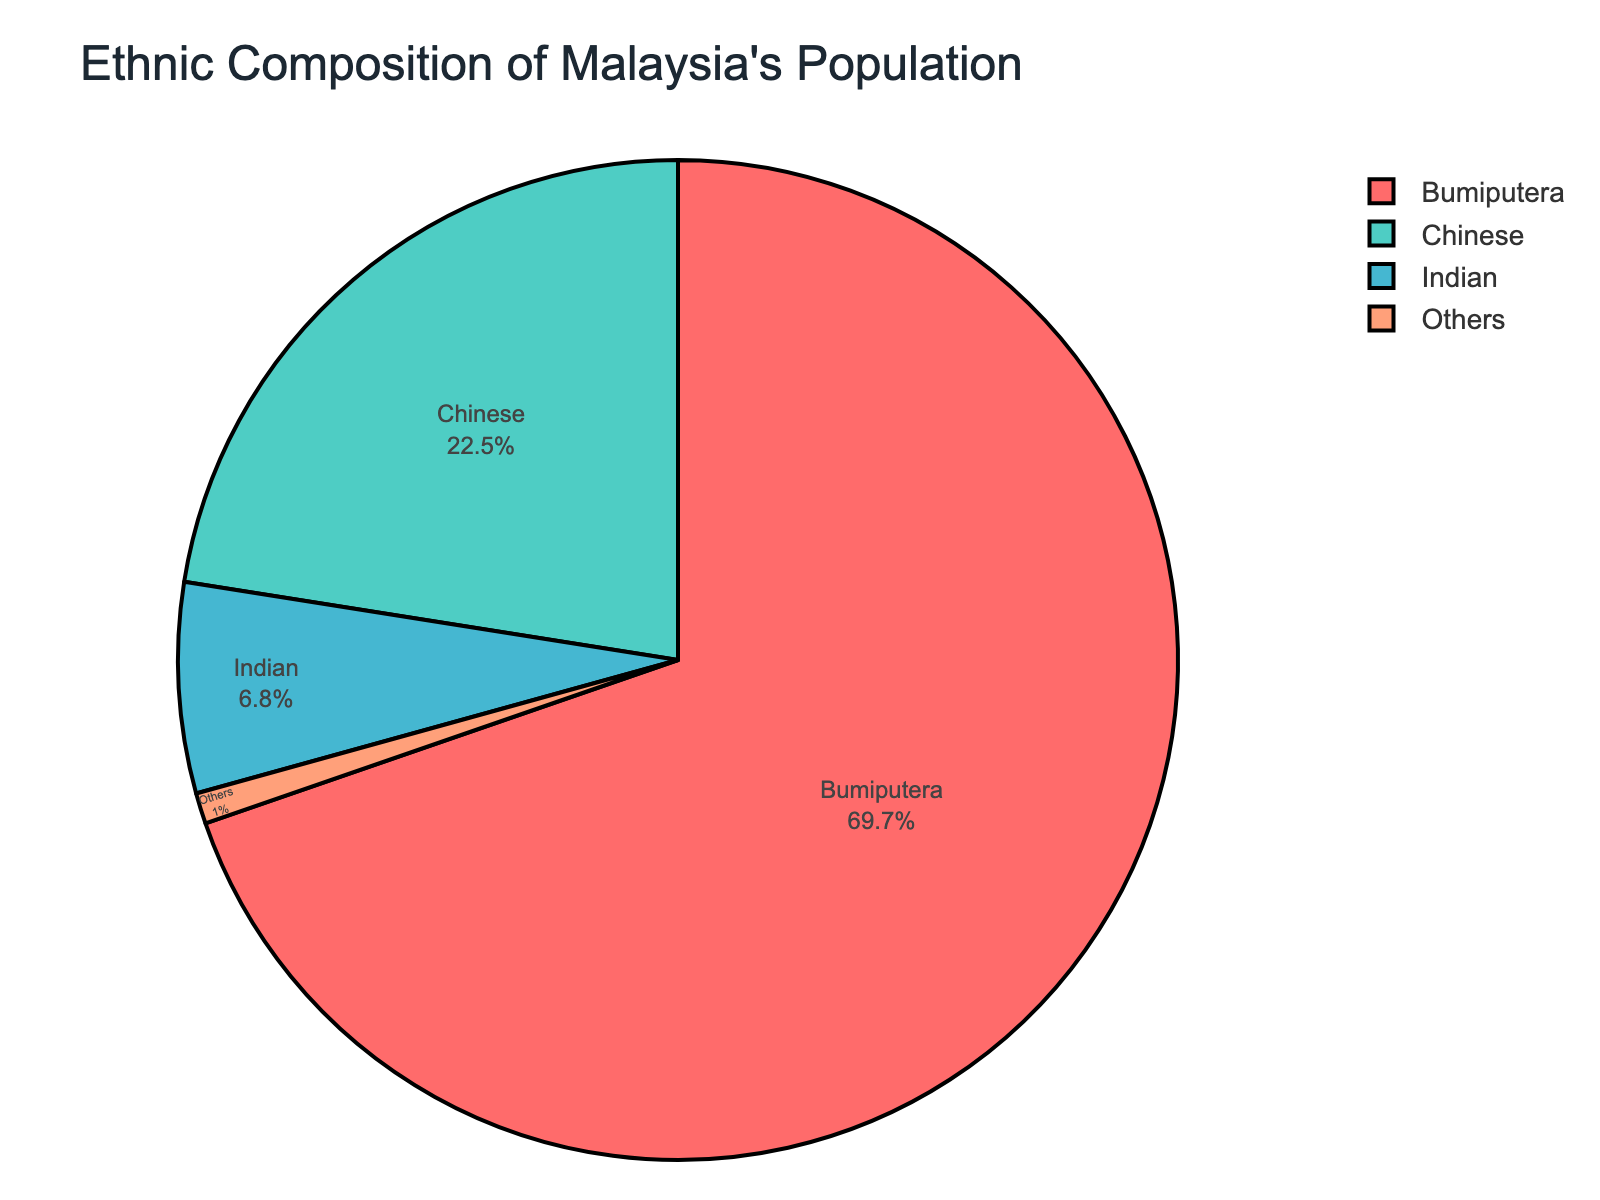Which ethnic group has the highest percentage? The pie chart shows multiple ethnic groups and their respective percentages. The group with the highest percentage is Bumiputera, which has 69.7% as listed in the chart.
Answer: Bumiputera What is the sum of the percentages of Chinese and Indian populations? The chart provides the percentages of Chinese and Indian populations. Adding these values: 22.5% (Chinese) + 6.8% (Indian) equals 29.3%.
Answer: 29.3% Which ethnic group has the smallest population percentage and what is it? The pie chart lists all ethnic groups with their percentages. The group with the smallest percentage is Others, with 1.0%.
Answer: Others, 1.0% How much larger is the Bumiputera population percentage compared to the Indian population percentage? The chart shows the Bumiputera percentage is 69.7% and the Indian percentage is 6.8%. Subtracting these values: 69.7% - 6.8% equals 62.9%.
Answer: 62.9% Combine the percentages of Bumiputera and Others; what fraction of the total population do they make up? Adding the percentages of Bumiputera (69.7%) and Others (1.0%): 69.7% + 1.0% equals 70.7%.
Answer: 70.7% Which ethnic populations combined make up roughly one-third of Malaysia's population? The chart shows the percentages of ethnic groups. Chinese (22.5%) and Indian (6.8%) combined equal 29.3%, which is close to one-third (33.3%).
Answer: Chinese and Indian Is the percentage of the Bumiputera population more than three times that of the Chinese population? The Bumiputera percentage is 69.7%, and the Chinese percentage is 22.5%. Multiplying the Chinese percentage by 3: 22.5% * 3 equals 67.5%, which is less than 69.7%.
Answer: Yes What is the difference in percentage points between the Chinese and Indian populations? The pie chart shows the Chinese percentage is 22.5% and the Indian percentage is 6.8%. Subtracting these values: 22.5% - 6.8% equals 15.7%.
Answer: 15.7% Which color represents the Chinese population in the pie chart? The pie chart colors should be examined. According to the provided code, the color for the Chinese population is '#4ECDC4'. However, ignoring hex codes, we identify this color as teal.
Answer: Teal 